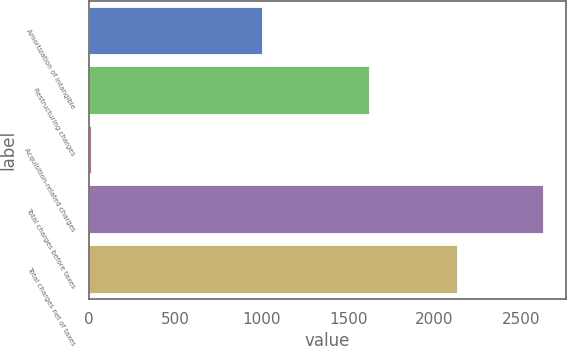Convert chart. <chart><loc_0><loc_0><loc_500><loc_500><bar_chart><fcel>Amortization of intangible<fcel>Restructuring charges<fcel>Acquisition-related charges<fcel>Total charges before taxes<fcel>Total charges net of taxes<nl><fcel>1000<fcel>1619<fcel>11<fcel>2630<fcel>2132<nl></chart> 